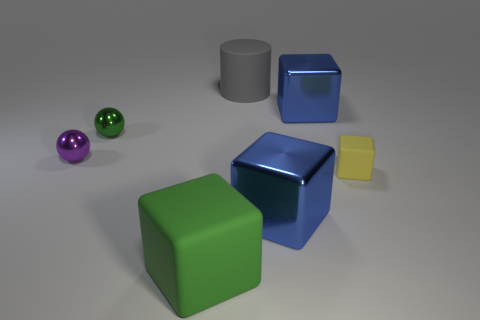Do the tiny yellow cube and the green object left of the large rubber block have the same material?
Provide a succinct answer. No. What is the material of the blue object behind the yellow object?
Provide a succinct answer. Metal. What size is the yellow matte cube?
Ensure brevity in your answer.  Small. Does the green shiny sphere in front of the large rubber cylinder have the same size as the blue object that is behind the purple thing?
Give a very brief answer. No. What is the size of the purple thing that is the same shape as the green metal object?
Offer a very short reply. Small. Does the green block have the same size as the gray rubber object that is behind the large green thing?
Keep it short and to the point. Yes. There is a tiny thing that is right of the cylinder; what shape is it?
Your answer should be compact. Cube. Does the green rubber object have the same size as the gray matte cylinder?
Your answer should be very brief. Yes. There is a small purple object that is the same shape as the green shiny thing; what is its material?
Give a very brief answer. Metal. What number of green balls have the same size as the purple sphere?
Keep it short and to the point. 1. 